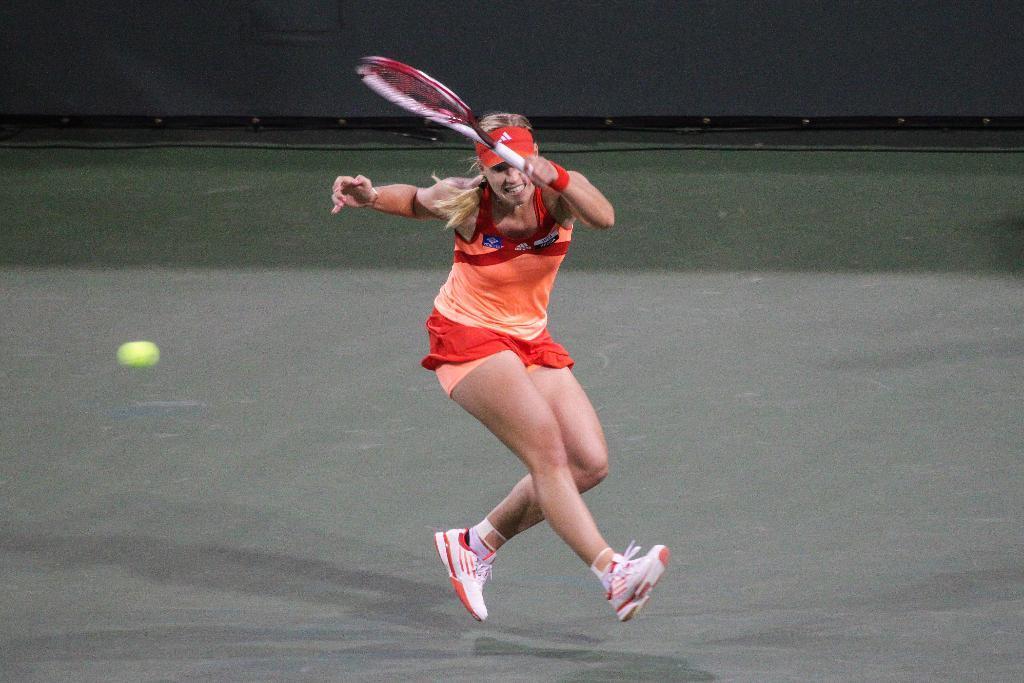In one or two sentences, can you explain what this image depicts? In this image there is a lady person wearing orange color dress playing tennis. 